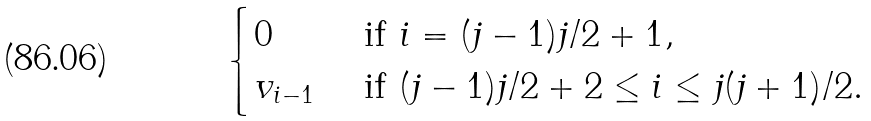Convert formula to latex. <formula><loc_0><loc_0><loc_500><loc_500>\begin{cases} 0 & \text { if } i = ( j - 1 ) j / 2 + 1 , \\ v _ { i - 1 } & \text { if } ( j - 1 ) j / 2 + 2 \leq i \leq j ( j + 1 ) / 2 . \\ \end{cases}</formula> 